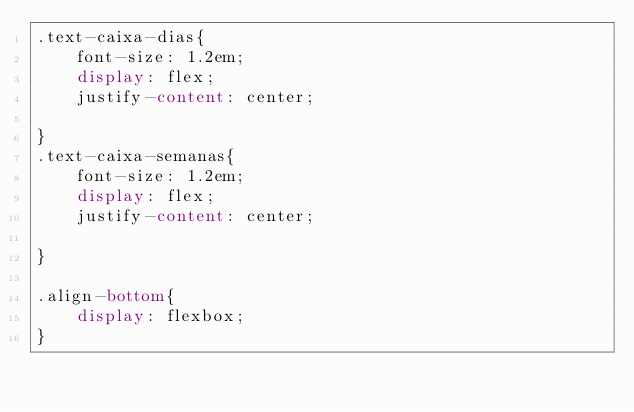Convert code to text. <code><loc_0><loc_0><loc_500><loc_500><_CSS_>.text-caixa-dias{
    font-size: 1.2em;
    display: flex;
    justify-content: center;
    
}
.text-caixa-semanas{
    font-size: 1.2em;
    display: flex;
    justify-content: center;

}

.align-bottom{
    display: flexbox;
}

</code> 